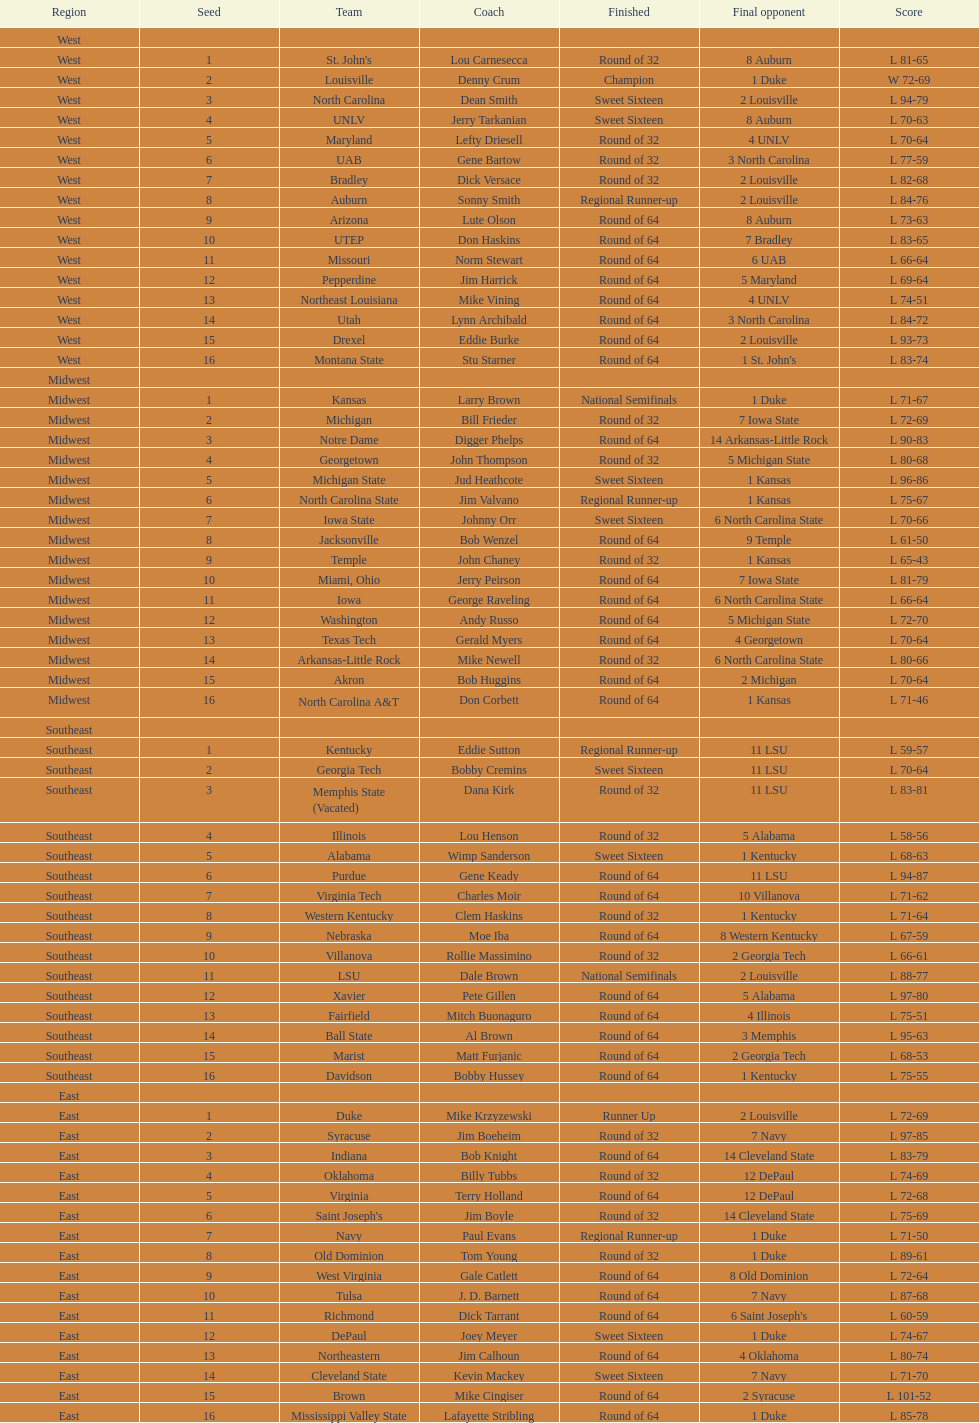How many number of teams played altogether? 64. 